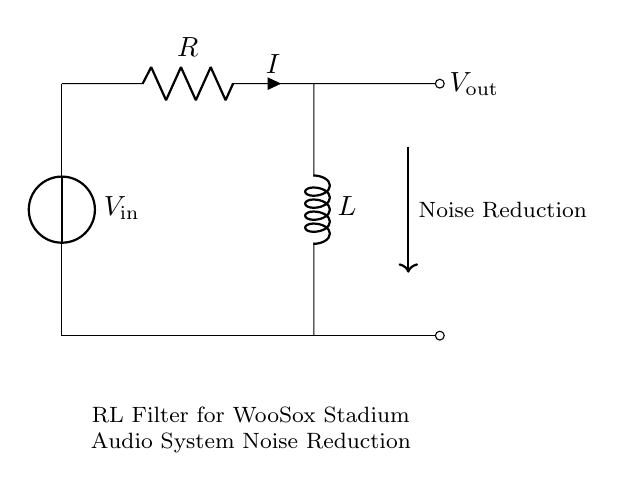What are the main components in this circuit? The circuit includes a voltage source, a resistor, and an inductor. Each component is essential for filtering noise, where the resistor limits current and the inductor opposes changes in current.
Answer: voltage source, resistor, inductor What is the purpose of this RL filter circuit? The primary purpose of this RL filter circuit is to reduce noise in the audio system of the WooSox stadium. The combination of resistor and inductor works to attenuate unwanted frequency components, allowing for cleaner audio output.
Answer: noise reduction What is the current direction in this circuit? The current flows from the positive terminal of the voltage source through the resistor, then through the inductor, and back to the negative terminal of the source. This establishes a loop in the circuit that is required for continuous flow.
Answer: clockwise Which component causes the noise reduction? The inductor is the component that primarily contributes to noise reduction by resisting changes in current. Its inductance allows it to store energy in a magnetic field, which mitigates abrupt increases in current that contribute to noise.
Answer: inductor What type of filter is represented by this RL circuit? This RL circuit acts as a low-pass filter, allowing low-frequency signals to pass while attenuating higher-frequency noise. This is particularly useful in audio applications where clarity is crucial.
Answer: low-pass filter What would happen if the resistance value increases? Increasing the resistance would result in a higher voltage drop across the resistor, reducing the current in the circuit. This may enhance the noise attenuation but could also lead to reduced audio signal strength, affecting overall performance.
Answer: reduced current 